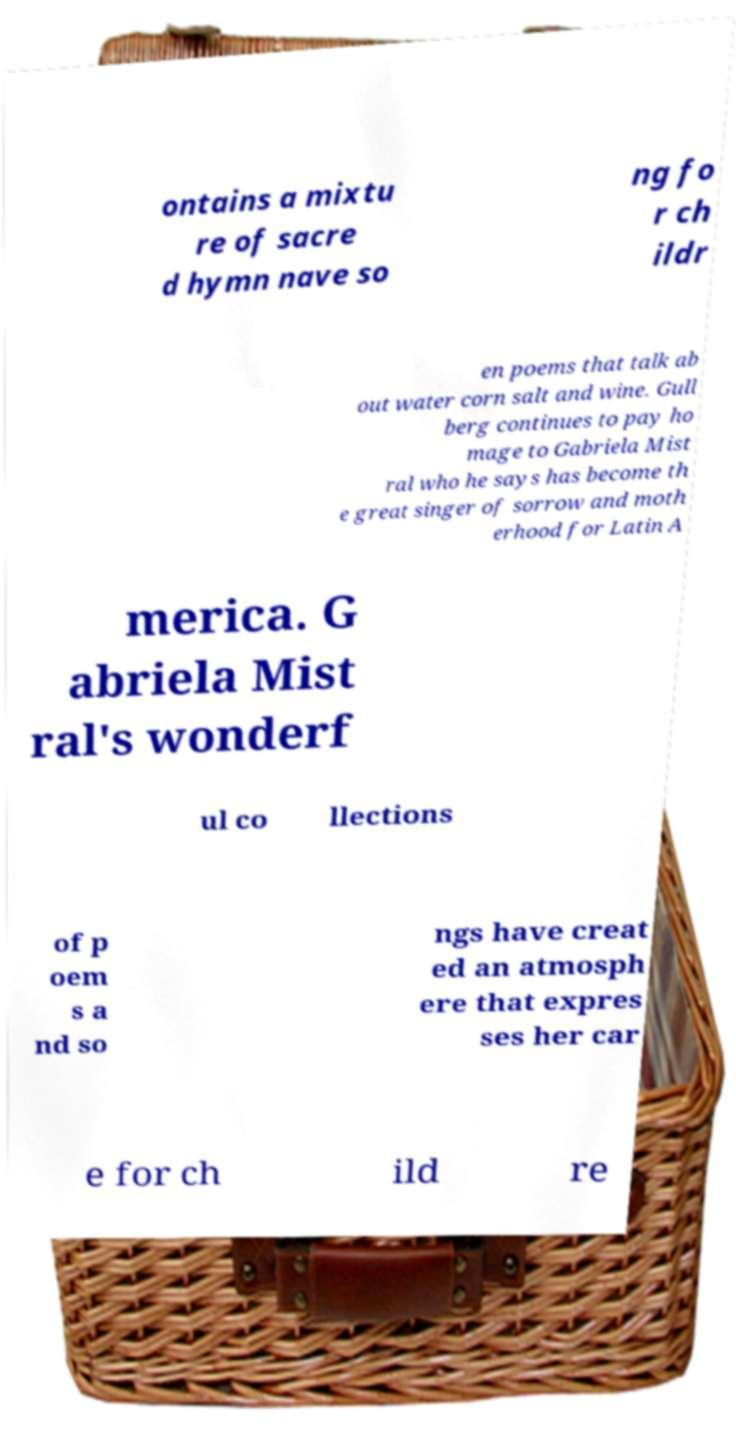Can you read and provide the text displayed in the image?This photo seems to have some interesting text. Can you extract and type it out for me? ontains a mixtu re of sacre d hymn nave so ng fo r ch ildr en poems that talk ab out water corn salt and wine. Gull berg continues to pay ho mage to Gabriela Mist ral who he says has become th e great singer of sorrow and moth erhood for Latin A merica. G abriela Mist ral's wonderf ul co llections of p oem s a nd so ngs have creat ed an atmosph ere that expres ses her car e for ch ild re 